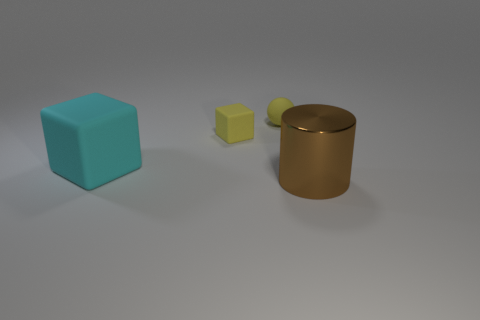Add 3 big cubes. How many objects exist? 7 Subtract all cylinders. How many objects are left? 3 Subtract all big cyan matte cubes. Subtract all yellow objects. How many objects are left? 1 Add 3 large brown objects. How many large brown objects are left? 4 Add 1 small yellow balls. How many small yellow balls exist? 2 Subtract 0 blue balls. How many objects are left? 4 